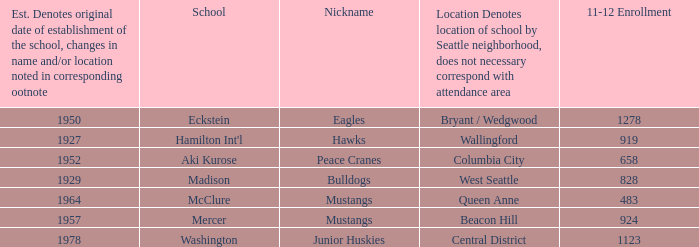Name the most 11-12 enrollment for columbia city 658.0. Can you give me this table as a dict? {'header': ['Est. Denotes original date of establishment of the school, changes in name and/or location noted in corresponding ootnote', 'School', 'Nickname', 'Location Denotes location of school by Seattle neighborhood, does not necessary correspond with attendance area', '11-12 Enrollment'], 'rows': [['1950', 'Eckstein', 'Eagles', 'Bryant / Wedgwood', '1278'], ['1927', "Hamilton Int'l", 'Hawks', 'Wallingford', '919'], ['1952', 'Aki Kurose', 'Peace Cranes', 'Columbia City', '658'], ['1929', 'Madison', 'Bulldogs', 'West Seattle', '828'], ['1964', 'McClure', 'Mustangs', 'Queen Anne', '483'], ['1957', 'Mercer', 'Mustangs', 'Beacon Hill', '924'], ['1978', 'Washington', 'Junior Huskies', 'Central District', '1123']]} 